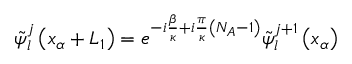Convert formula to latex. <formula><loc_0><loc_0><loc_500><loc_500>{ \tilde { \psi } } _ { l } ^ { j } \left ( x _ { \alpha } + L _ { 1 } \right ) = e ^ { - i \frac { \beta } { \kappa } + i \frac { \pi } { \kappa } \left ( N _ { A } - 1 \right ) } { \tilde { \psi } } _ { l } ^ { j + 1 } \left ( x _ { \alpha } \right )</formula> 